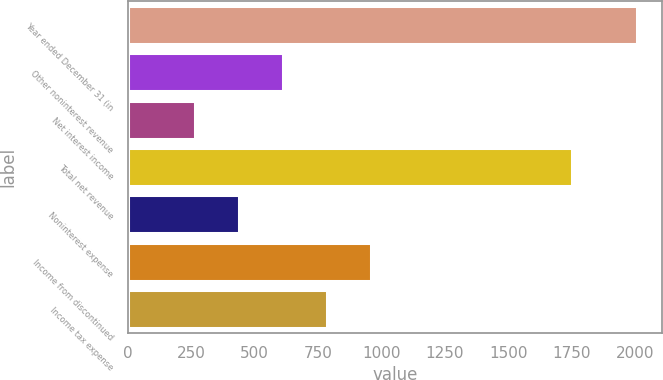<chart> <loc_0><loc_0><loc_500><loc_500><bar_chart><fcel>Year ended December 31 (in<fcel>Other noninterest revenue<fcel>Net interest income<fcel>Total net revenue<fcel>Noninterest expense<fcel>Income from discontinued<fcel>Income tax expense<nl><fcel>2006<fcel>612.4<fcel>264<fcel>1752<fcel>438.2<fcel>960.8<fcel>786.6<nl></chart> 